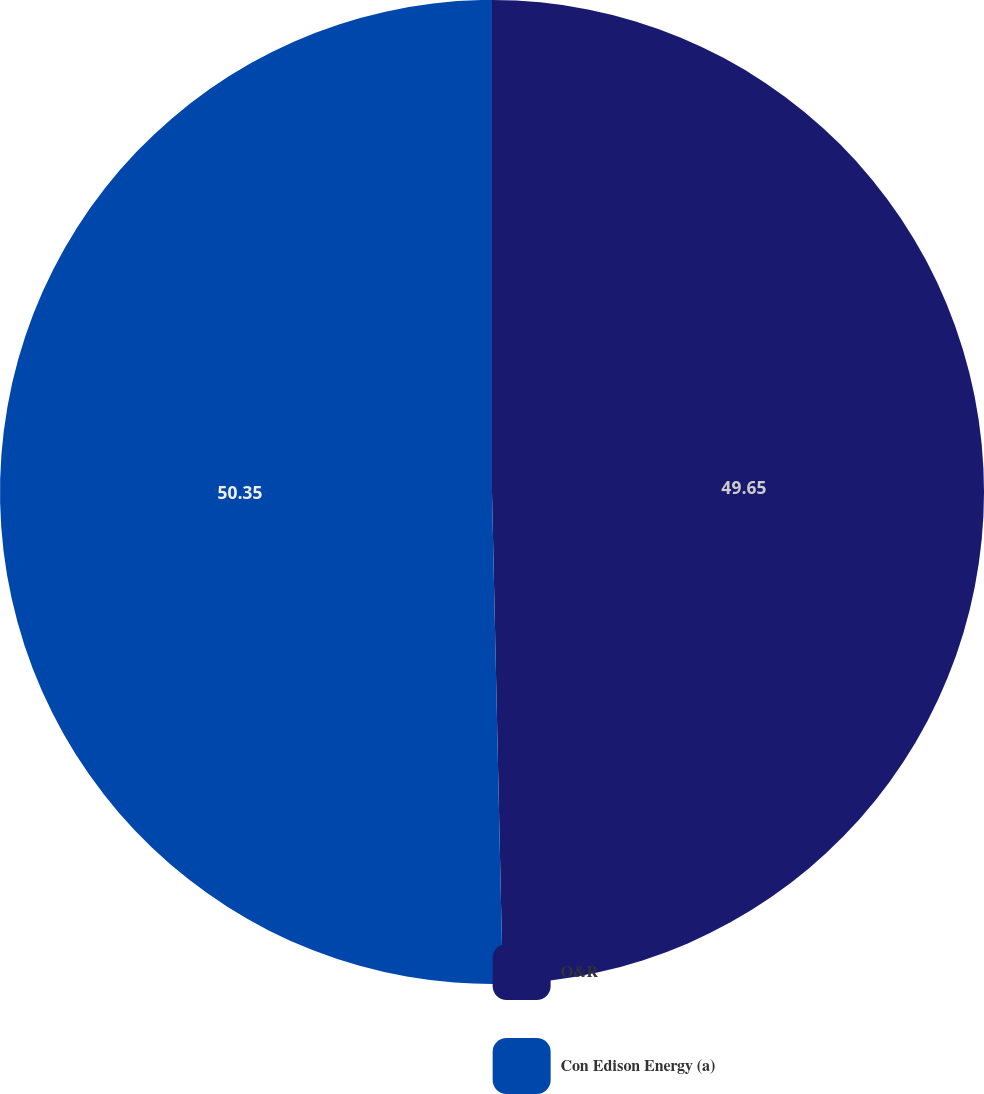Convert chart to OTSL. <chart><loc_0><loc_0><loc_500><loc_500><pie_chart><fcel>O&R<fcel>Con Edison Energy (a)<nl><fcel>49.65%<fcel>50.35%<nl></chart> 